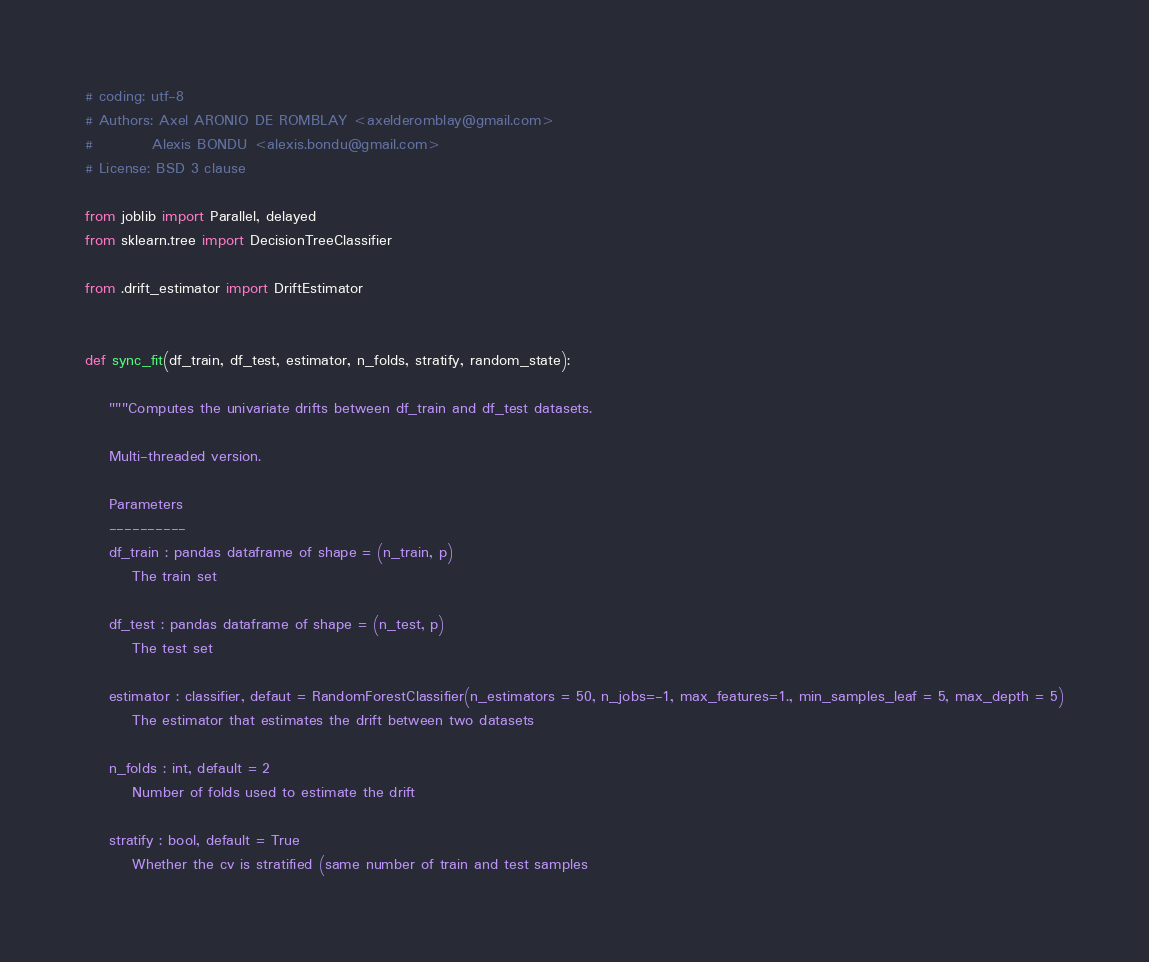Convert code to text. <code><loc_0><loc_0><loc_500><loc_500><_Python_># coding: utf-8
# Authors: Axel ARONIO DE ROMBLAY <axelderomblay@gmail.com>
#          Alexis BONDU <alexis.bondu@gmail.com>
# License: BSD 3 clause

from joblib import Parallel, delayed
from sklearn.tree import DecisionTreeClassifier

from .drift_estimator import DriftEstimator


def sync_fit(df_train, df_test, estimator, n_folds, stratify, random_state):

    """Computes the univariate drifts between df_train and df_test datasets.

    Multi-threaded version.

    Parameters
    ----------
    df_train : pandas dataframe of shape = (n_train, p)
        The train set

    df_test : pandas dataframe of shape = (n_test, p)
        The test set

    estimator : classifier, defaut = RandomForestClassifier(n_estimators = 50, n_jobs=-1, max_features=1., min_samples_leaf = 5, max_depth = 5)
        The estimator that estimates the drift between two datasets

    n_folds : int, default = 2
        Number of folds used to estimate the drift

    stratify : bool, default = True
        Whether the cv is stratified (same number of train and test samples</code> 